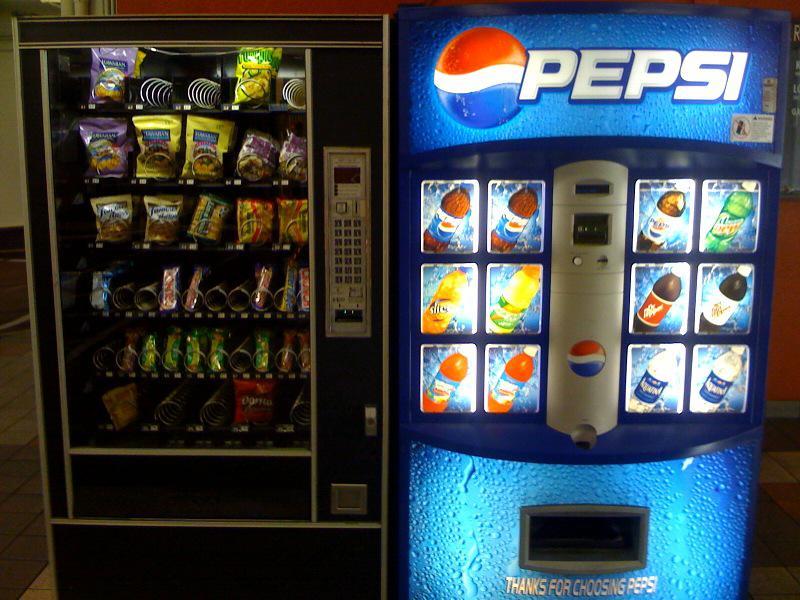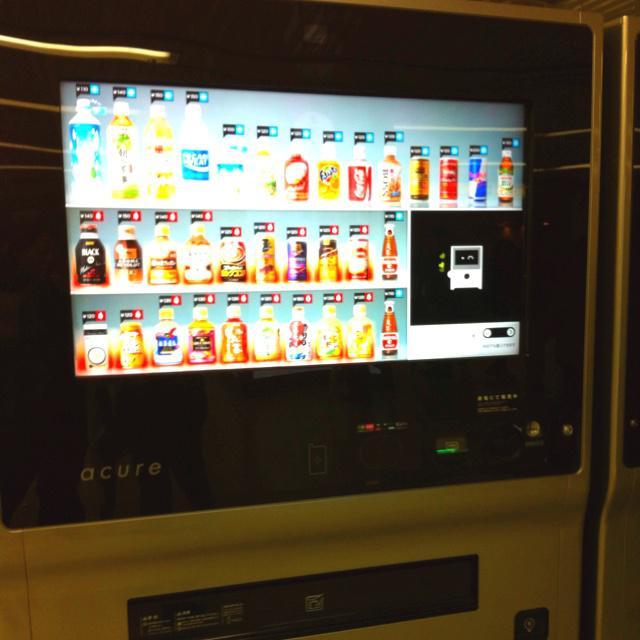The first image is the image on the left, the second image is the image on the right. Assess this claim about the two images: "None of the images show more than two vending machines.". Correct or not? Answer yes or no. Yes. The first image is the image on the left, the second image is the image on the right. Evaluate the accuracy of this statement regarding the images: "There are no more than two vending machines in the image on the right.". Is it true? Answer yes or no. Yes. 